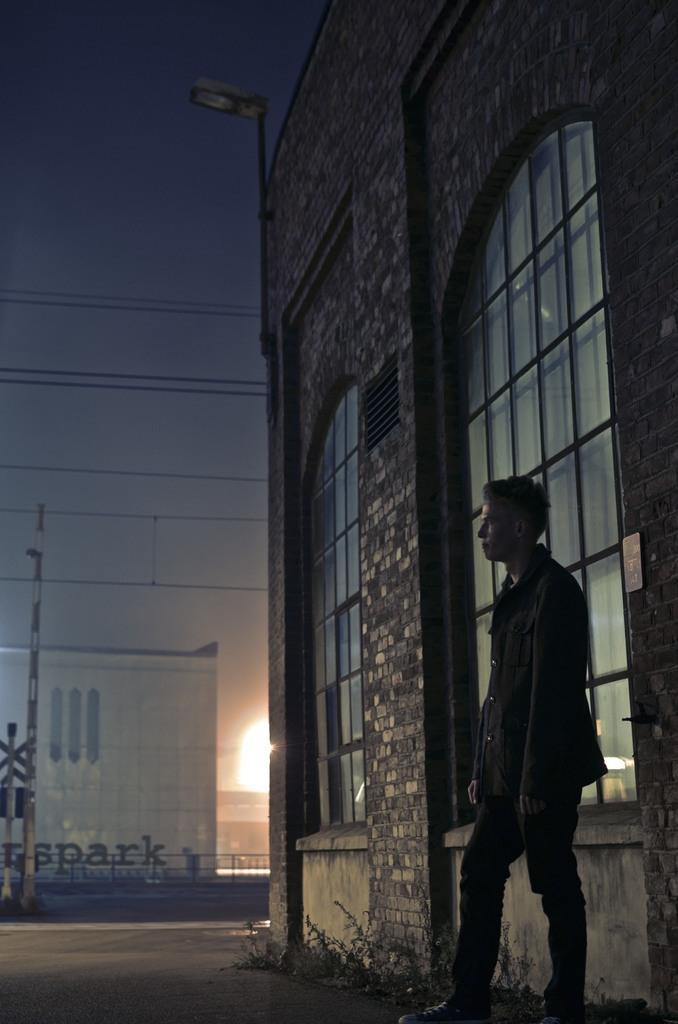Describe this image in one or two sentences. This picture is clicked outside. On the right there is a person seems to be standing on the ground and we can see the plants. In the background we can see the sky, light, cables, poles and buildings. 